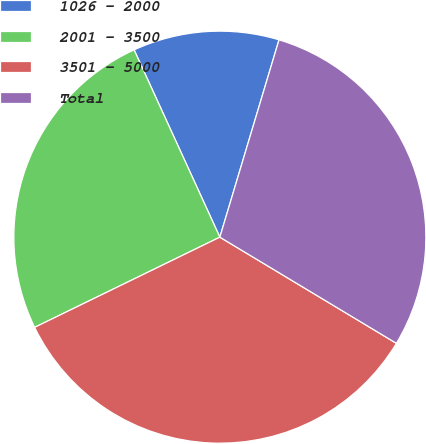Convert chart. <chart><loc_0><loc_0><loc_500><loc_500><pie_chart><fcel>1026 - 2000<fcel>2001 - 3500<fcel>3501 - 5000<fcel>Total<nl><fcel>11.47%<fcel>25.38%<fcel>34.17%<fcel>28.98%<nl></chart> 